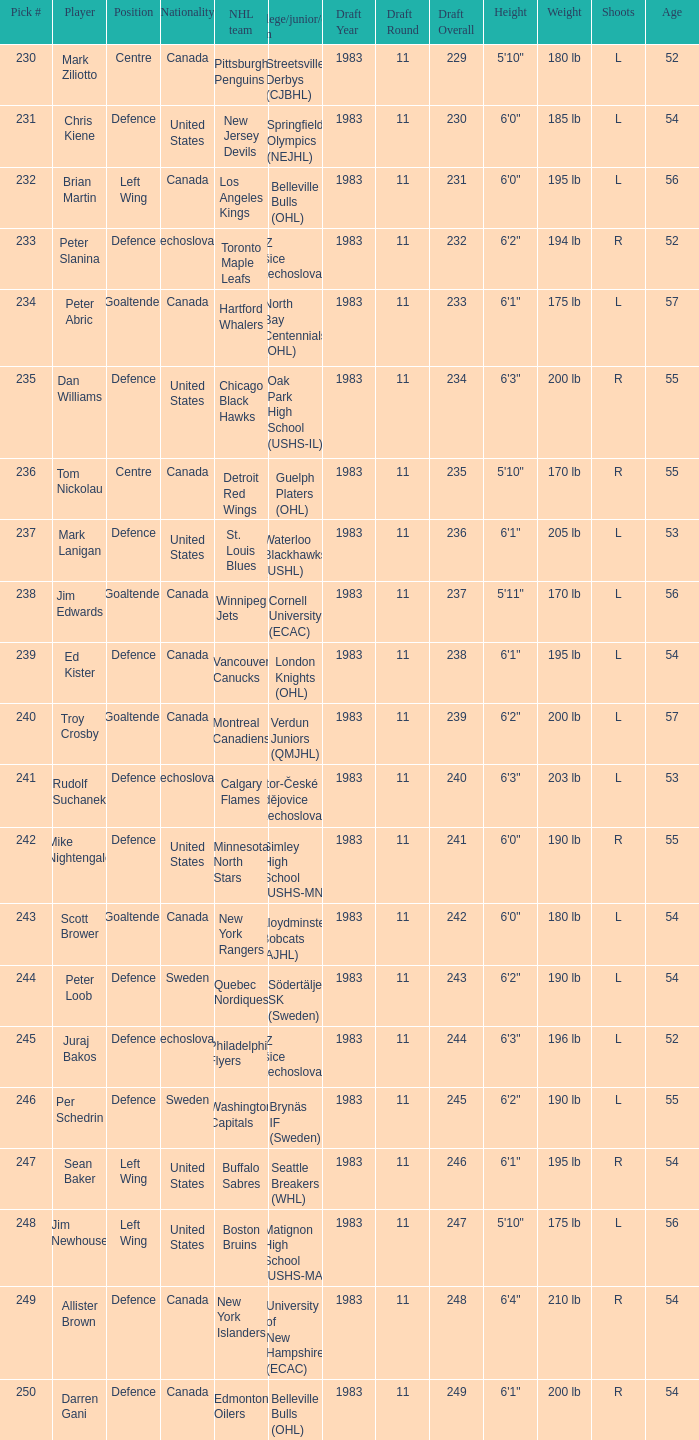Can you provide the names of the players on brynäs if team in sweden? Per Schedrin. 